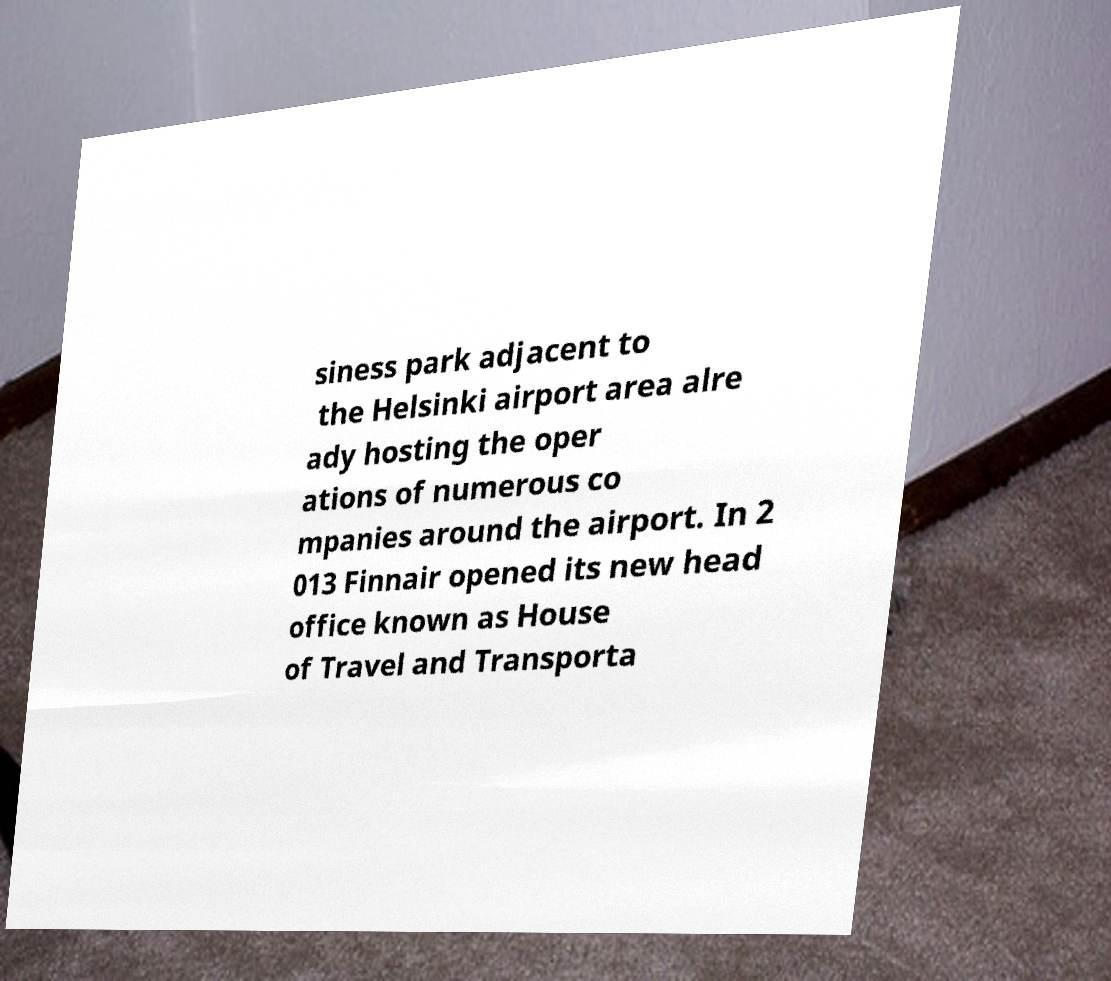Please identify and transcribe the text found in this image. siness park adjacent to the Helsinki airport area alre ady hosting the oper ations of numerous co mpanies around the airport. In 2 013 Finnair opened its new head office known as House of Travel and Transporta 